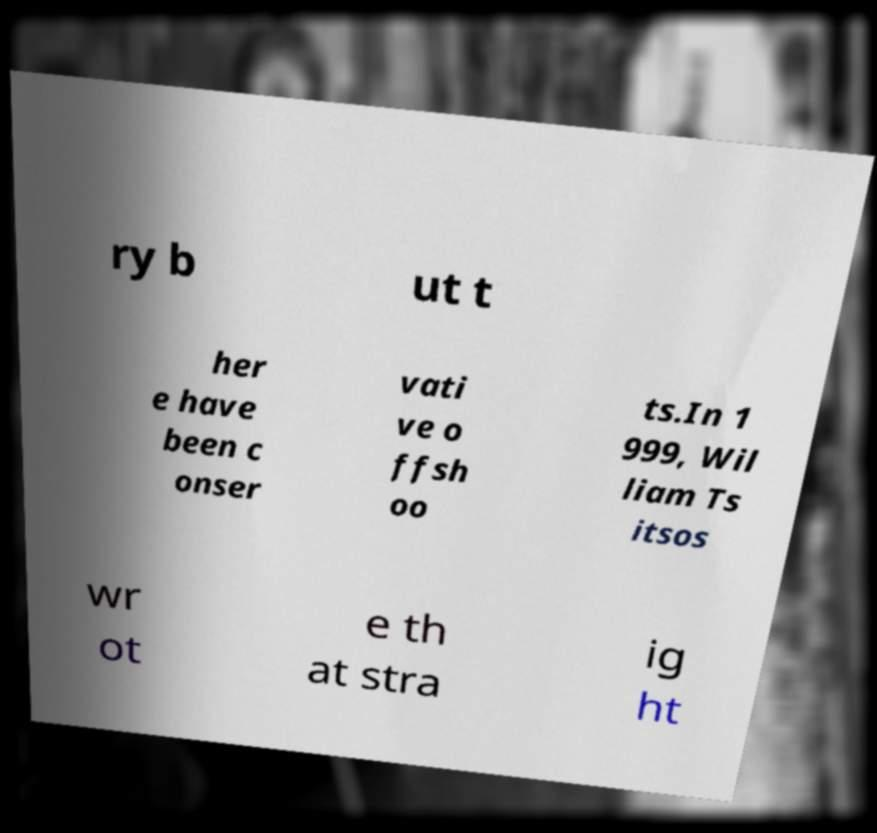Please read and relay the text visible in this image. What does it say? ry b ut t her e have been c onser vati ve o ffsh oo ts.In 1 999, Wil liam Ts itsos wr ot e th at stra ig ht 